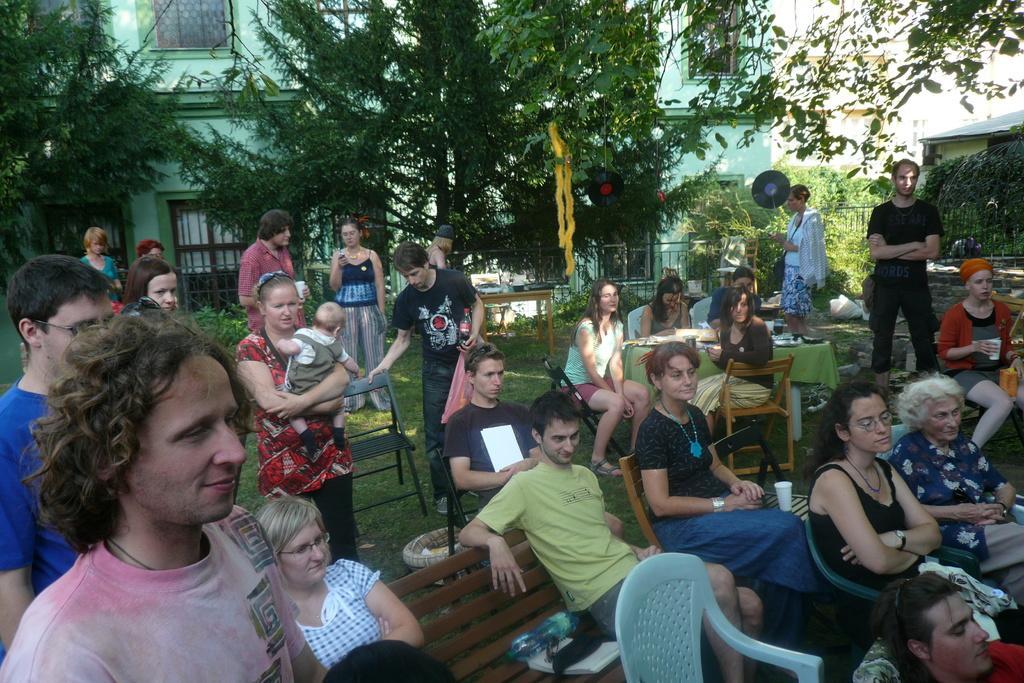Can you describe this image briefly? there are so many people sitting and standing in a garden behind and there is a trees and building. 